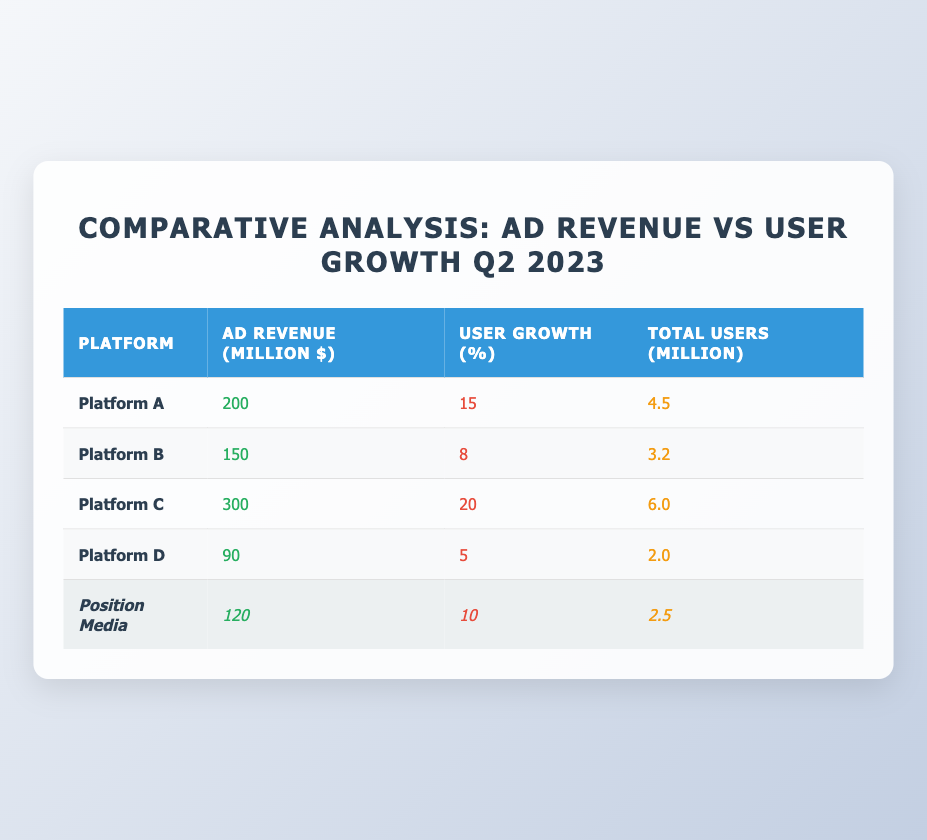What is the ad revenue of Platform C? The table shows the ad revenue figures for each platform. Looking at the row for Platform C, the ad revenue is listed as 300 million dollars.
Answer: 300 million dollars Which platform has the highest user growth percentage in Q2 2023? By examining the user growth percentages in the table, Platform C has the value of 20%, which is the highest compared to all other platforms listed.
Answer: Platform C What is the combined ad revenue of all platforms? To find the combined ad revenue, we add up all the ad revenues from each platform: 200 + 150 + 300 + 90 + 120 = 860 million dollars.
Answer: 860 million dollars Is Platform D's user growth higher than Position Media's? Platform D shows user growth of 5%, while Position Media shows 10%. Hence, Platform D does not have higher user growth than Position Media, making the statement false.
Answer: No What is the total number of users for all platforms combined? We calculate the total users by adding the total users from each platform: 4.5 + 3.2 + 6.0 + 2.0 + 2.5 = 18.2 million users.
Answer: 18.2 million users What is the difference between the ad revenue of Platform A and Platform B? The ad revenue for Platform A is 200 million dollars, and for Platform B, it is 150 million dollars. The difference is calculated as 200 - 150 = 50 million dollars.
Answer: 50 million dollars Does Platform A have more total users than Platform B? Platform A has 4.5 million total users, while Platform B has 3.2 million total users. Since 4.5 is greater than 3.2, the answer is yes.
Answer: Yes Which platform has the least ad revenue, and what is that amount? Looking through the table, Platform D has the lowest ad revenue at 90 million dollars, making it the platform with the least ad revenue.
Answer: Platform D, 90 million dollars What is the average user growth percentage across all platforms? To find the average, we add the user growth percentages (15 + 8 + 20 + 5 + 10 = 58) and then divide by the number of platforms (5), resulting in 58 / 5 = 11.6%.
Answer: 11.6% 